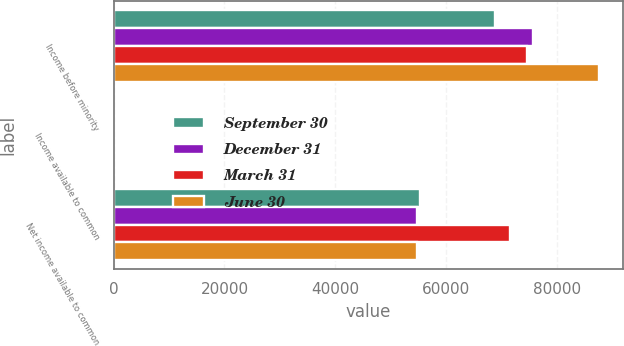Convert chart. <chart><loc_0><loc_0><loc_500><loc_500><stacked_bar_chart><ecel><fcel>Income before minority<fcel>Income available to common<fcel>Net income available to common<nl><fcel>September 30<fcel>68848<fcel>0.6<fcel>55365<nl><fcel>December 31<fcel>75823<fcel>0.59<fcel>54775<nl><fcel>March 31<fcel>74626<fcel>0.74<fcel>71541<nl><fcel>June 30<fcel>87643<fcel>2.72<fcel>54775<nl></chart> 